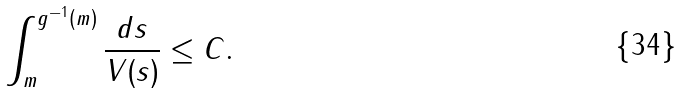Convert formula to latex. <formula><loc_0><loc_0><loc_500><loc_500>\int _ { m } ^ { g ^ { - 1 } ( m ) } \frac { d s } { V ( s ) } \leq C .</formula> 